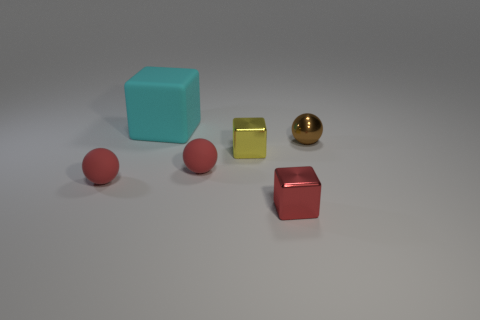Subtract all matte blocks. How many blocks are left? 2 Subtract 1 spheres. How many spheres are left? 2 Add 2 tiny cyan shiny spheres. How many objects exist? 8 Add 3 yellow metallic cubes. How many yellow metallic cubes are left? 4 Add 4 big green cubes. How many big green cubes exist? 4 Subtract 0 brown blocks. How many objects are left? 6 Subtract all large brown metallic blocks. Subtract all red matte things. How many objects are left? 4 